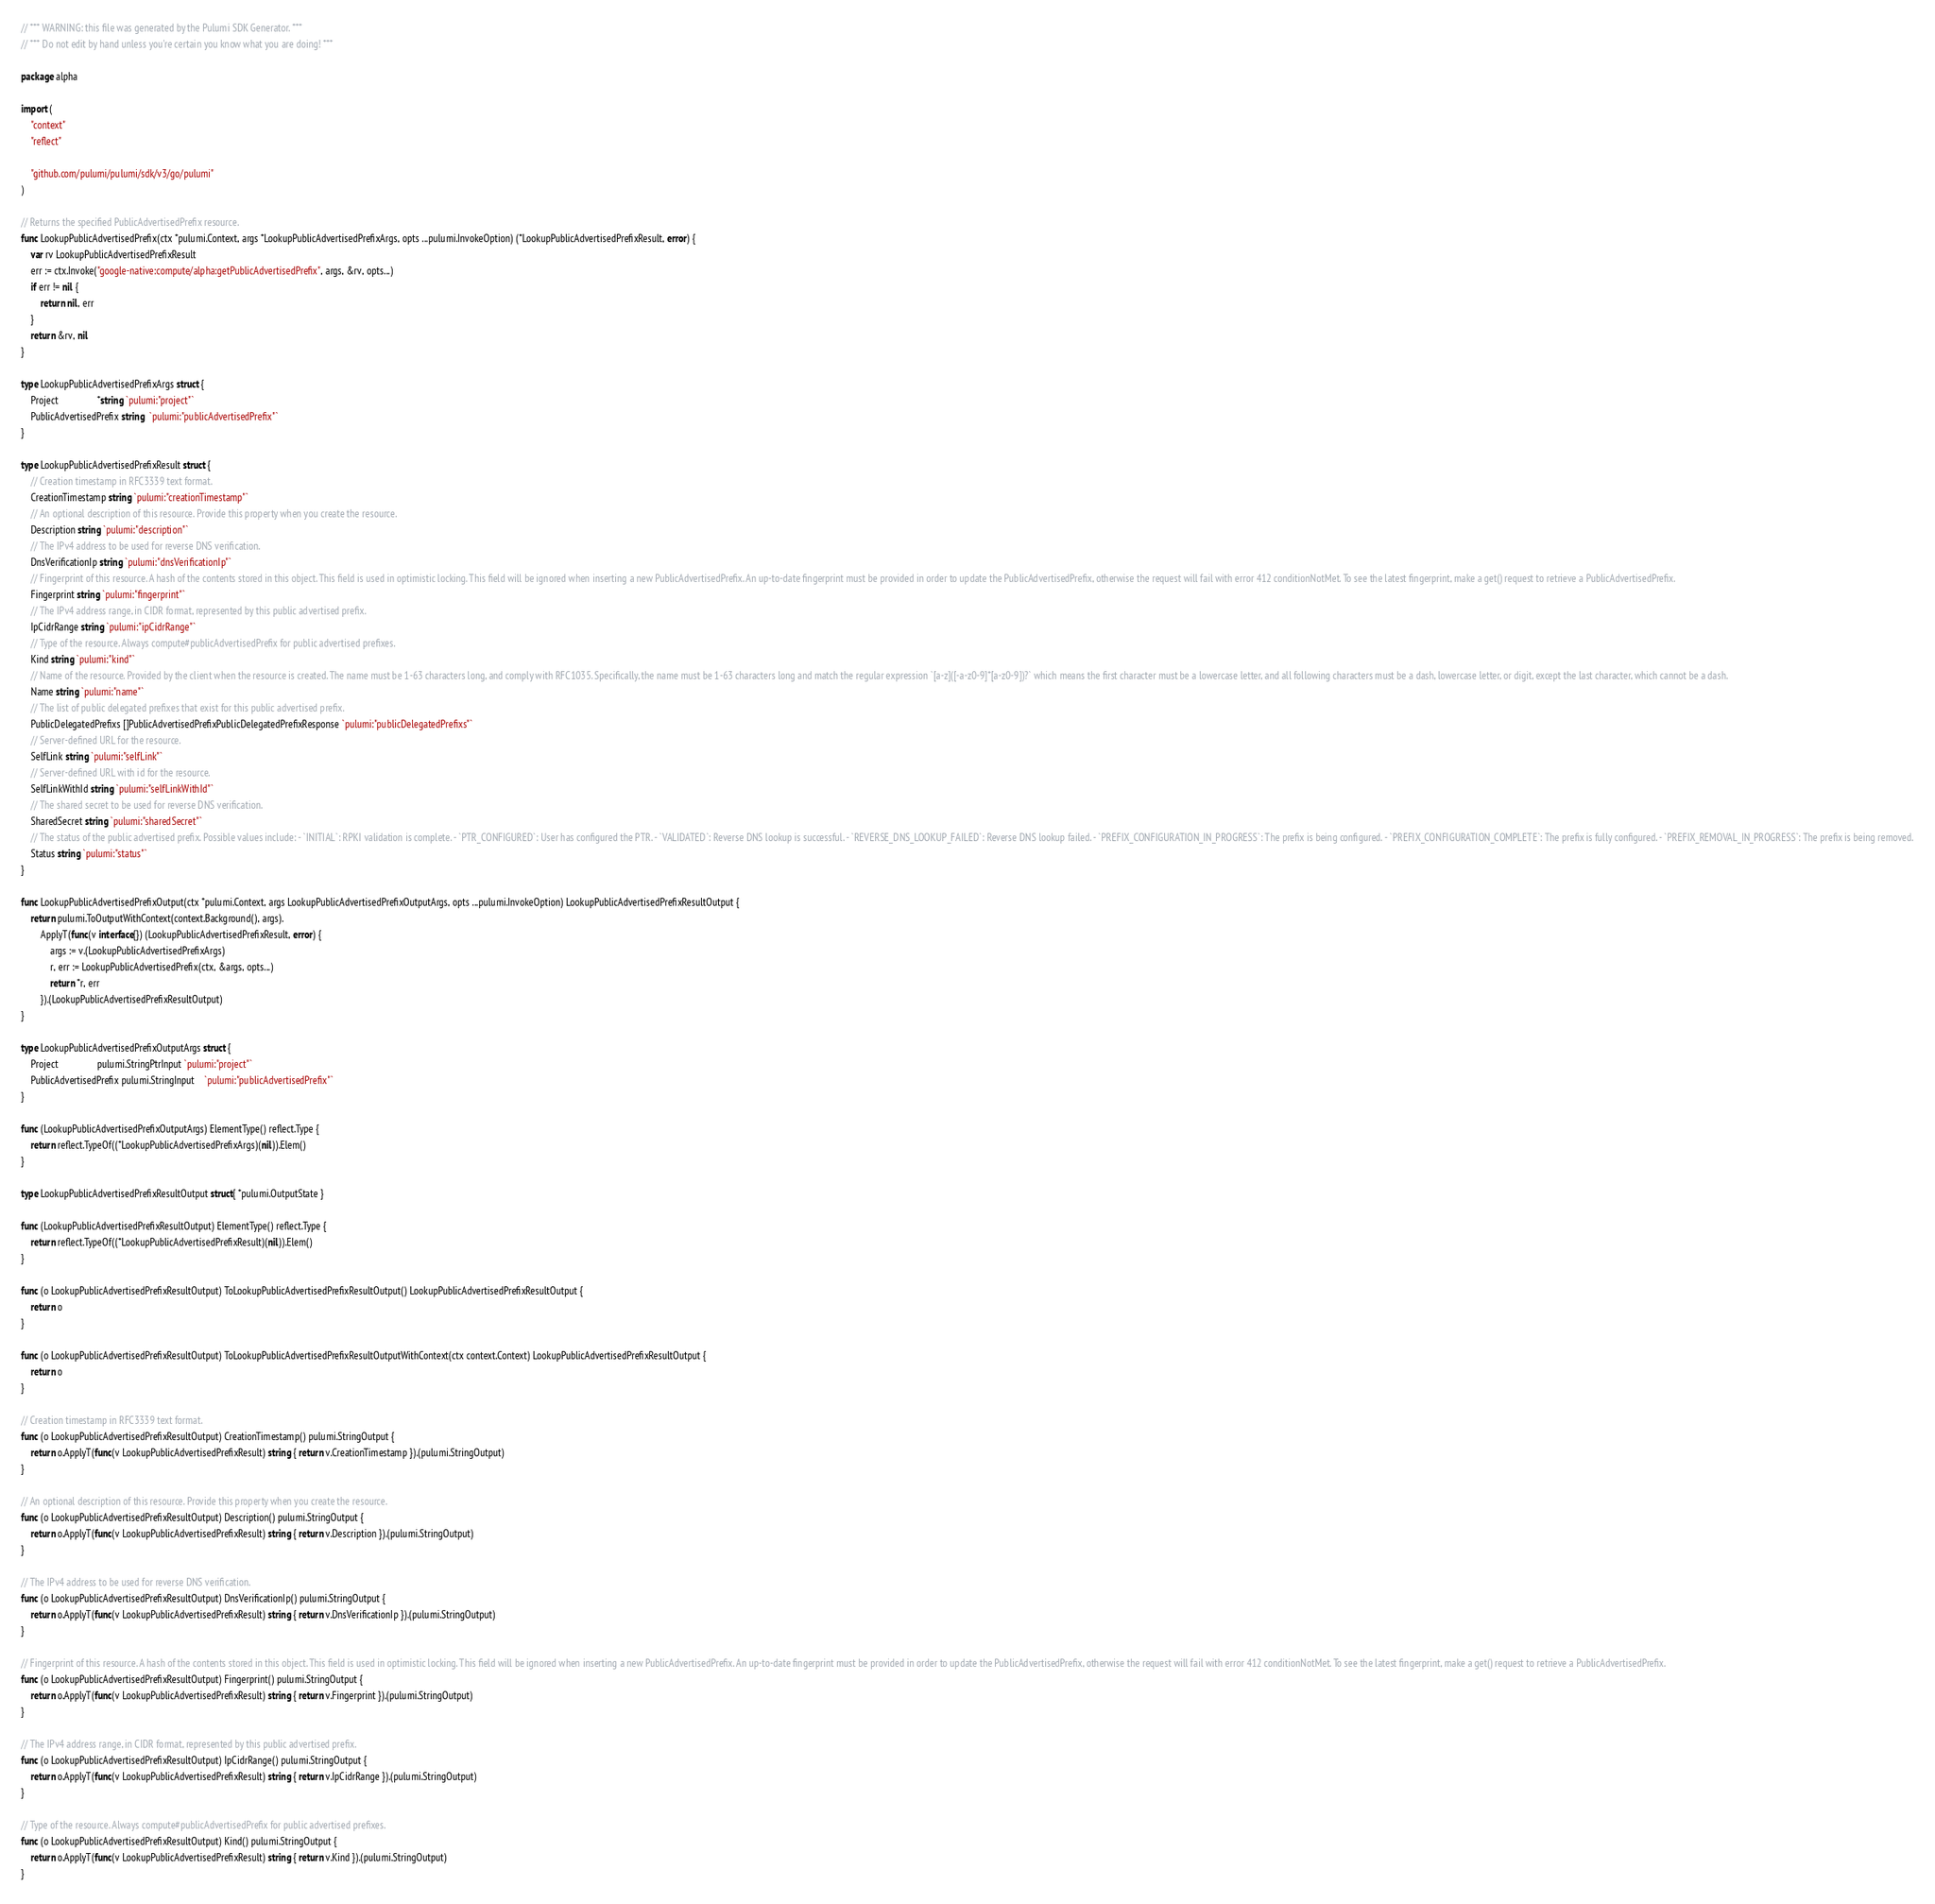Convert code to text. <code><loc_0><loc_0><loc_500><loc_500><_Go_>// *** WARNING: this file was generated by the Pulumi SDK Generator. ***
// *** Do not edit by hand unless you're certain you know what you are doing! ***

package alpha

import (
	"context"
	"reflect"

	"github.com/pulumi/pulumi/sdk/v3/go/pulumi"
)

// Returns the specified PublicAdvertisedPrefix resource.
func LookupPublicAdvertisedPrefix(ctx *pulumi.Context, args *LookupPublicAdvertisedPrefixArgs, opts ...pulumi.InvokeOption) (*LookupPublicAdvertisedPrefixResult, error) {
	var rv LookupPublicAdvertisedPrefixResult
	err := ctx.Invoke("google-native:compute/alpha:getPublicAdvertisedPrefix", args, &rv, opts...)
	if err != nil {
		return nil, err
	}
	return &rv, nil
}

type LookupPublicAdvertisedPrefixArgs struct {
	Project                *string `pulumi:"project"`
	PublicAdvertisedPrefix string  `pulumi:"publicAdvertisedPrefix"`
}

type LookupPublicAdvertisedPrefixResult struct {
	// Creation timestamp in RFC3339 text format.
	CreationTimestamp string `pulumi:"creationTimestamp"`
	// An optional description of this resource. Provide this property when you create the resource.
	Description string `pulumi:"description"`
	// The IPv4 address to be used for reverse DNS verification.
	DnsVerificationIp string `pulumi:"dnsVerificationIp"`
	// Fingerprint of this resource. A hash of the contents stored in this object. This field is used in optimistic locking. This field will be ignored when inserting a new PublicAdvertisedPrefix. An up-to-date fingerprint must be provided in order to update the PublicAdvertisedPrefix, otherwise the request will fail with error 412 conditionNotMet. To see the latest fingerprint, make a get() request to retrieve a PublicAdvertisedPrefix.
	Fingerprint string `pulumi:"fingerprint"`
	// The IPv4 address range, in CIDR format, represented by this public advertised prefix.
	IpCidrRange string `pulumi:"ipCidrRange"`
	// Type of the resource. Always compute#publicAdvertisedPrefix for public advertised prefixes.
	Kind string `pulumi:"kind"`
	// Name of the resource. Provided by the client when the resource is created. The name must be 1-63 characters long, and comply with RFC1035. Specifically, the name must be 1-63 characters long and match the regular expression `[a-z]([-a-z0-9]*[a-z0-9])?` which means the first character must be a lowercase letter, and all following characters must be a dash, lowercase letter, or digit, except the last character, which cannot be a dash.
	Name string `pulumi:"name"`
	// The list of public delegated prefixes that exist for this public advertised prefix.
	PublicDelegatedPrefixs []PublicAdvertisedPrefixPublicDelegatedPrefixResponse `pulumi:"publicDelegatedPrefixs"`
	// Server-defined URL for the resource.
	SelfLink string `pulumi:"selfLink"`
	// Server-defined URL with id for the resource.
	SelfLinkWithId string `pulumi:"selfLinkWithId"`
	// The shared secret to be used for reverse DNS verification.
	SharedSecret string `pulumi:"sharedSecret"`
	// The status of the public advertised prefix. Possible values include: - `INITIAL`: RPKI validation is complete. - `PTR_CONFIGURED`: User has configured the PTR. - `VALIDATED`: Reverse DNS lookup is successful. - `REVERSE_DNS_LOOKUP_FAILED`: Reverse DNS lookup failed. - `PREFIX_CONFIGURATION_IN_PROGRESS`: The prefix is being configured. - `PREFIX_CONFIGURATION_COMPLETE`: The prefix is fully configured. - `PREFIX_REMOVAL_IN_PROGRESS`: The prefix is being removed.
	Status string `pulumi:"status"`
}

func LookupPublicAdvertisedPrefixOutput(ctx *pulumi.Context, args LookupPublicAdvertisedPrefixOutputArgs, opts ...pulumi.InvokeOption) LookupPublicAdvertisedPrefixResultOutput {
	return pulumi.ToOutputWithContext(context.Background(), args).
		ApplyT(func(v interface{}) (LookupPublicAdvertisedPrefixResult, error) {
			args := v.(LookupPublicAdvertisedPrefixArgs)
			r, err := LookupPublicAdvertisedPrefix(ctx, &args, opts...)
			return *r, err
		}).(LookupPublicAdvertisedPrefixResultOutput)
}

type LookupPublicAdvertisedPrefixOutputArgs struct {
	Project                pulumi.StringPtrInput `pulumi:"project"`
	PublicAdvertisedPrefix pulumi.StringInput    `pulumi:"publicAdvertisedPrefix"`
}

func (LookupPublicAdvertisedPrefixOutputArgs) ElementType() reflect.Type {
	return reflect.TypeOf((*LookupPublicAdvertisedPrefixArgs)(nil)).Elem()
}

type LookupPublicAdvertisedPrefixResultOutput struct{ *pulumi.OutputState }

func (LookupPublicAdvertisedPrefixResultOutput) ElementType() reflect.Type {
	return reflect.TypeOf((*LookupPublicAdvertisedPrefixResult)(nil)).Elem()
}

func (o LookupPublicAdvertisedPrefixResultOutput) ToLookupPublicAdvertisedPrefixResultOutput() LookupPublicAdvertisedPrefixResultOutput {
	return o
}

func (o LookupPublicAdvertisedPrefixResultOutput) ToLookupPublicAdvertisedPrefixResultOutputWithContext(ctx context.Context) LookupPublicAdvertisedPrefixResultOutput {
	return o
}

// Creation timestamp in RFC3339 text format.
func (o LookupPublicAdvertisedPrefixResultOutput) CreationTimestamp() pulumi.StringOutput {
	return o.ApplyT(func(v LookupPublicAdvertisedPrefixResult) string { return v.CreationTimestamp }).(pulumi.StringOutput)
}

// An optional description of this resource. Provide this property when you create the resource.
func (o LookupPublicAdvertisedPrefixResultOutput) Description() pulumi.StringOutput {
	return o.ApplyT(func(v LookupPublicAdvertisedPrefixResult) string { return v.Description }).(pulumi.StringOutput)
}

// The IPv4 address to be used for reverse DNS verification.
func (o LookupPublicAdvertisedPrefixResultOutput) DnsVerificationIp() pulumi.StringOutput {
	return o.ApplyT(func(v LookupPublicAdvertisedPrefixResult) string { return v.DnsVerificationIp }).(pulumi.StringOutput)
}

// Fingerprint of this resource. A hash of the contents stored in this object. This field is used in optimistic locking. This field will be ignored when inserting a new PublicAdvertisedPrefix. An up-to-date fingerprint must be provided in order to update the PublicAdvertisedPrefix, otherwise the request will fail with error 412 conditionNotMet. To see the latest fingerprint, make a get() request to retrieve a PublicAdvertisedPrefix.
func (o LookupPublicAdvertisedPrefixResultOutput) Fingerprint() pulumi.StringOutput {
	return o.ApplyT(func(v LookupPublicAdvertisedPrefixResult) string { return v.Fingerprint }).(pulumi.StringOutput)
}

// The IPv4 address range, in CIDR format, represented by this public advertised prefix.
func (o LookupPublicAdvertisedPrefixResultOutput) IpCidrRange() pulumi.StringOutput {
	return o.ApplyT(func(v LookupPublicAdvertisedPrefixResult) string { return v.IpCidrRange }).(pulumi.StringOutput)
}

// Type of the resource. Always compute#publicAdvertisedPrefix for public advertised prefixes.
func (o LookupPublicAdvertisedPrefixResultOutput) Kind() pulumi.StringOutput {
	return o.ApplyT(func(v LookupPublicAdvertisedPrefixResult) string { return v.Kind }).(pulumi.StringOutput)
}
</code> 